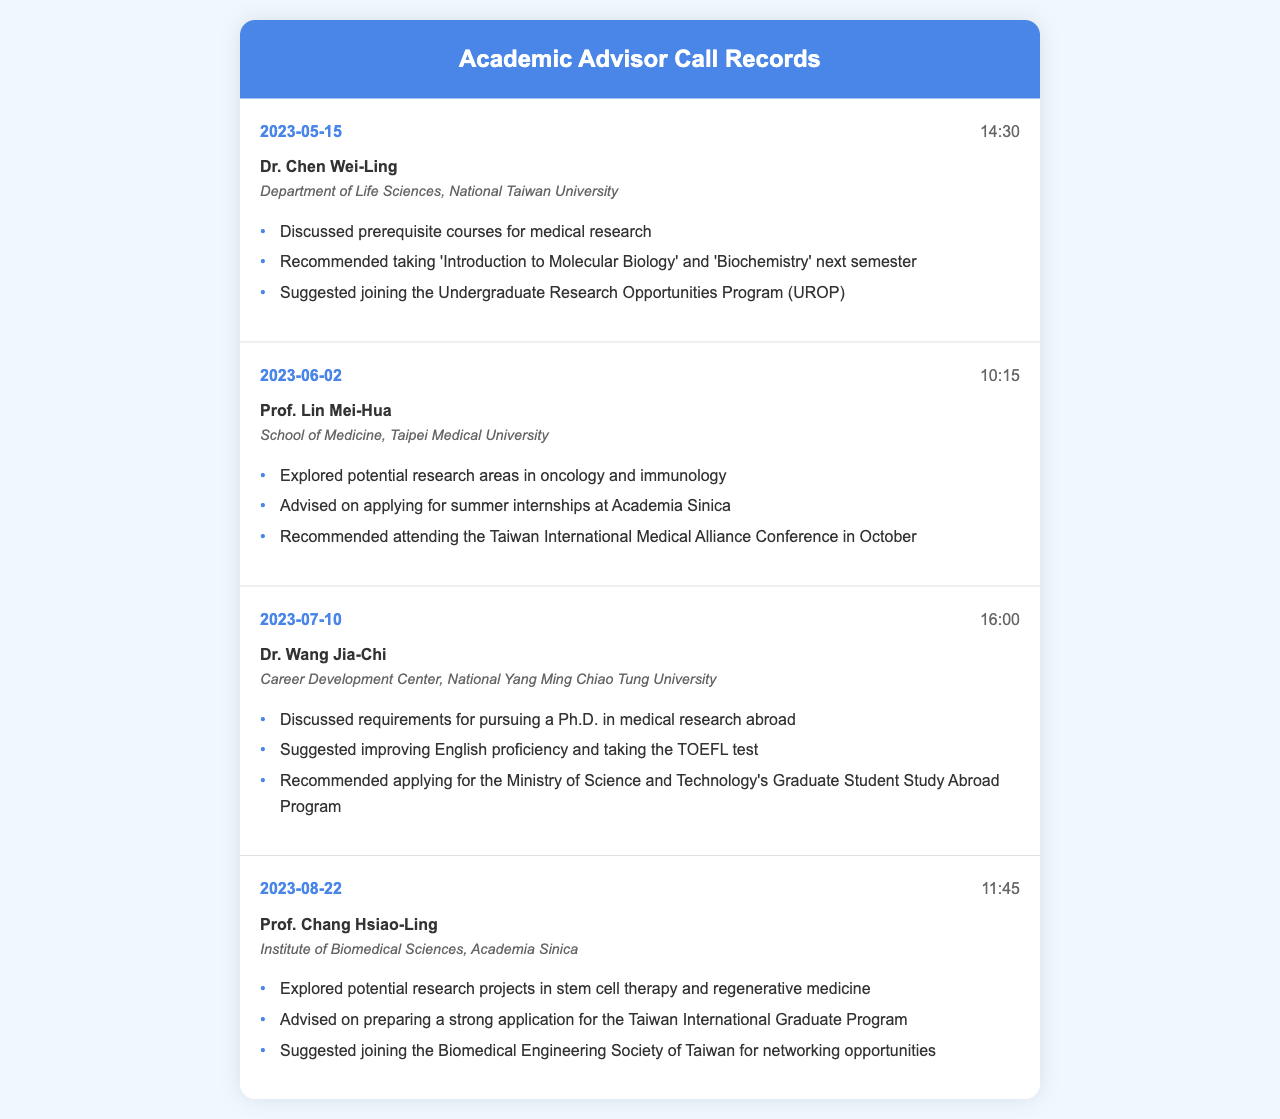What is the date of the first call? The date of the first call is listed as the earliest record in the document, which is 2023-05-15.
Answer: 2023-05-15 Who is the advisor from the School of Medicine? The advisor from the School of Medicine is identified as Prof. Lin Mei-Hua.
Answer: Prof. Lin Mei-Hua What course was recommended in the first consultation? The specific course recommended in the first consultation is noted to be 'Introduction to Molecular Biology'.
Answer: 'Introduction to Molecular Biology' How many calls were made in total? The total number of calls is determined by counting each call record presented in the document, resulting in four calls.
Answer: 4 What research area did Prof. Chang Hsiao-Ling discuss? The research area discussed by Prof. Chang Hsiao-Ling includes stem cell therapy and regenerative medicine.
Answer: stem cell therapy and regenerative medicine What did Dr. Wang Jia-Chi suggest improving? Dr. Wang Jia-Chi suggested improving English proficiency during the consultation.
Answer: English proficiency Which department is Dr. Chen Wei-Ling affiliated with? Dr. Chen Wei-Ling is affiliated with the Department of Life Sciences at National Taiwan University.
Answer: Department of Life Sciences, National Taiwan University What is the main focus of the topic discussed on 2023-06-02? The main focus of the topic discussed on that date centers around potential research areas in oncology and immunology.
Answer: oncology and immunology What program was suggested to join for networking opportunities? The program suggested to join for networking opportunities is the Biomedical Engineering Society of Taiwan.
Answer: Biomedical Engineering Society of Taiwan 